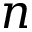<formula> <loc_0><loc_0><loc_500><loc_500>n</formula> 